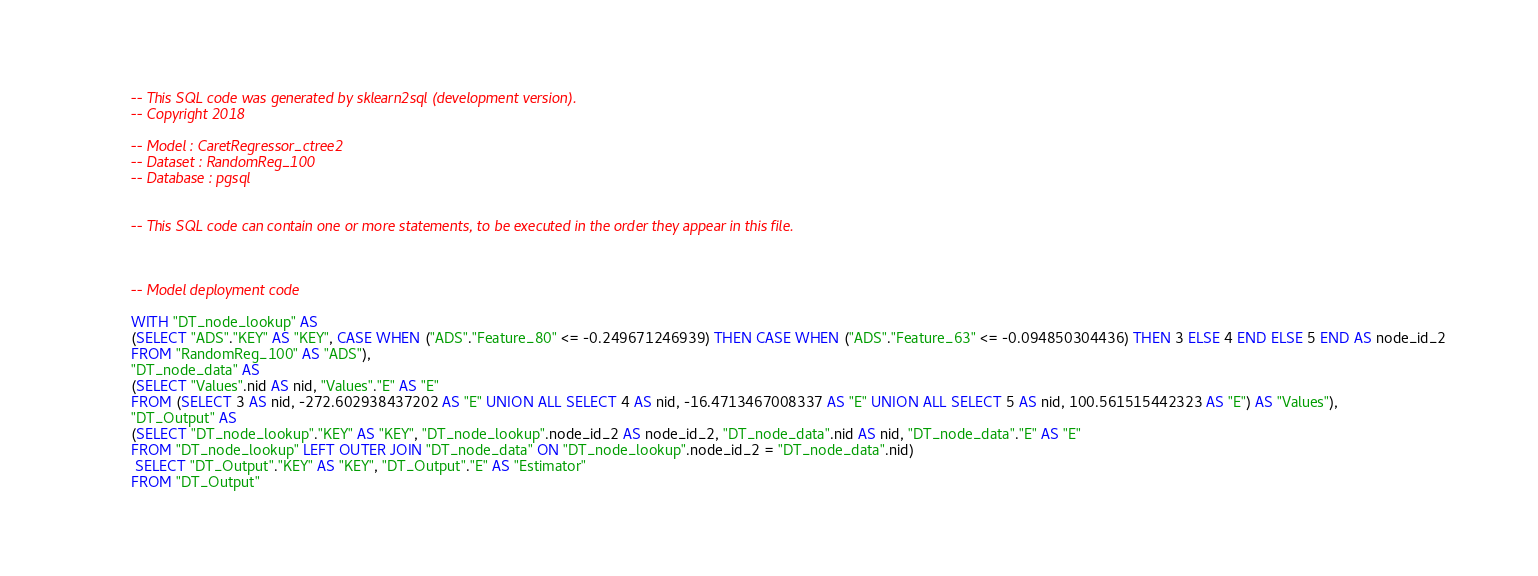Convert code to text. <code><loc_0><loc_0><loc_500><loc_500><_SQL_>-- This SQL code was generated by sklearn2sql (development version).
-- Copyright 2018

-- Model : CaretRegressor_ctree2
-- Dataset : RandomReg_100
-- Database : pgsql


-- This SQL code can contain one or more statements, to be executed in the order they appear in this file.



-- Model deployment code

WITH "DT_node_lookup" AS 
(SELECT "ADS"."KEY" AS "KEY", CASE WHEN ("ADS"."Feature_80" <= -0.249671246939) THEN CASE WHEN ("ADS"."Feature_63" <= -0.094850304436) THEN 3 ELSE 4 END ELSE 5 END AS node_id_2 
FROM "RandomReg_100" AS "ADS"), 
"DT_node_data" AS 
(SELECT "Values".nid AS nid, "Values"."E" AS "E" 
FROM (SELECT 3 AS nid, -272.602938437202 AS "E" UNION ALL SELECT 4 AS nid, -16.4713467008337 AS "E" UNION ALL SELECT 5 AS nid, 100.561515442323 AS "E") AS "Values"), 
"DT_Output" AS 
(SELECT "DT_node_lookup"."KEY" AS "KEY", "DT_node_lookup".node_id_2 AS node_id_2, "DT_node_data".nid AS nid, "DT_node_data"."E" AS "E" 
FROM "DT_node_lookup" LEFT OUTER JOIN "DT_node_data" ON "DT_node_lookup".node_id_2 = "DT_node_data".nid)
 SELECT "DT_Output"."KEY" AS "KEY", "DT_Output"."E" AS "Estimator" 
FROM "DT_Output"</code> 